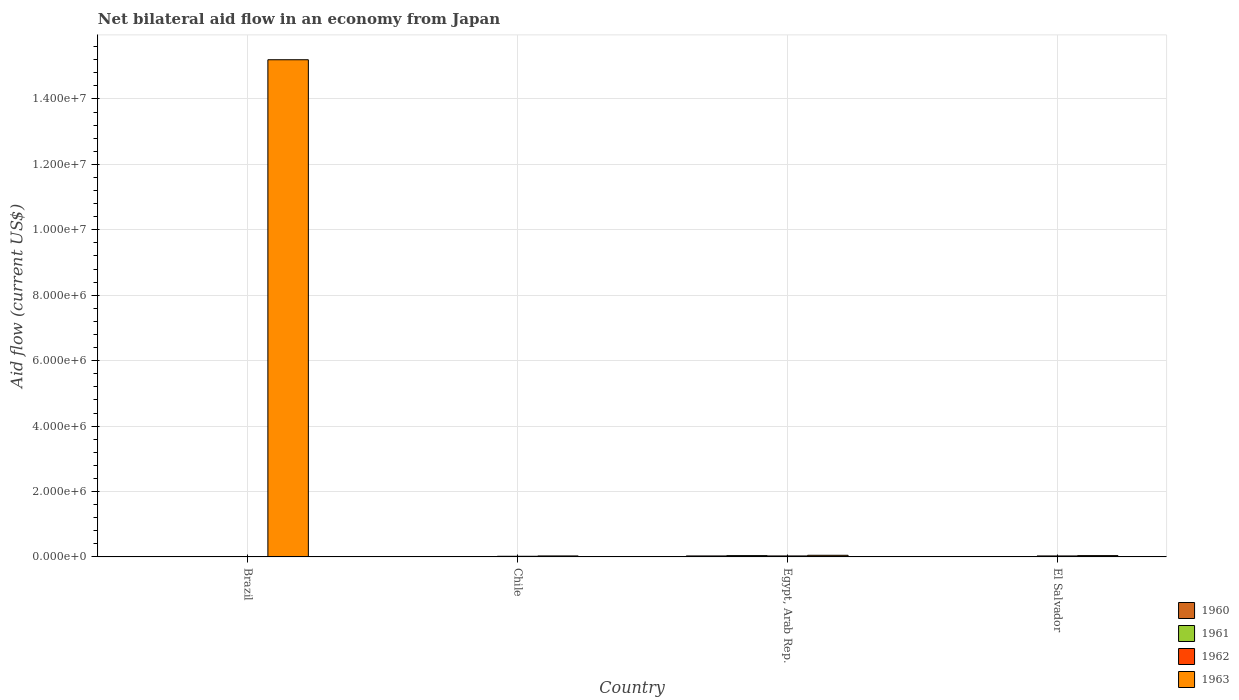Are the number of bars per tick equal to the number of legend labels?
Your answer should be compact. No. Are the number of bars on each tick of the X-axis equal?
Make the answer very short. No. How many bars are there on the 2nd tick from the left?
Provide a succinct answer. 4. What is the label of the 2nd group of bars from the left?
Your answer should be compact. Chile. What is the net bilateral aid flow in 1960 in Brazil?
Provide a succinct answer. 0. Across all countries, what is the maximum net bilateral aid flow in 1963?
Provide a succinct answer. 1.52e+07. In which country was the net bilateral aid flow in 1960 maximum?
Your answer should be very brief. Egypt, Arab Rep. What is the total net bilateral aid flow in 1963 in the graph?
Keep it short and to the point. 1.53e+07. What is the difference between the net bilateral aid flow in 1960 in Egypt, Arab Rep. and that in El Salvador?
Offer a very short reply. 2.00e+04. What is the difference between the net bilateral aid flow in 1962 in Egypt, Arab Rep. and the net bilateral aid flow in 1960 in El Salvador?
Provide a succinct answer. 2.00e+04. What is the average net bilateral aid flow in 1961 per country?
Keep it short and to the point. 1.50e+04. What is the difference between the net bilateral aid flow of/in 1963 and net bilateral aid flow of/in 1962 in El Salvador?
Keep it short and to the point. 10000. Is the difference between the net bilateral aid flow in 1963 in Chile and Egypt, Arab Rep. greater than the difference between the net bilateral aid flow in 1962 in Chile and Egypt, Arab Rep.?
Offer a terse response. No. What is the difference between the highest and the second highest net bilateral aid flow in 1962?
Offer a very short reply. 10000. In how many countries, is the net bilateral aid flow in 1960 greater than the average net bilateral aid flow in 1960 taken over all countries?
Give a very brief answer. 1. Is the sum of the net bilateral aid flow in 1963 in Brazil and Chile greater than the maximum net bilateral aid flow in 1961 across all countries?
Provide a short and direct response. Yes. Is it the case that in every country, the sum of the net bilateral aid flow in 1961 and net bilateral aid flow in 1963 is greater than the sum of net bilateral aid flow in 1962 and net bilateral aid flow in 1960?
Offer a terse response. No. Is it the case that in every country, the sum of the net bilateral aid flow in 1963 and net bilateral aid flow in 1961 is greater than the net bilateral aid flow in 1962?
Offer a very short reply. Yes. Are all the bars in the graph horizontal?
Offer a terse response. No. Are the values on the major ticks of Y-axis written in scientific E-notation?
Give a very brief answer. Yes. How are the legend labels stacked?
Your answer should be very brief. Vertical. What is the title of the graph?
Your answer should be compact. Net bilateral aid flow in an economy from Japan. Does "1976" appear as one of the legend labels in the graph?
Make the answer very short. No. What is the Aid flow (current US$) of 1960 in Brazil?
Your response must be concise. 0. What is the Aid flow (current US$) in 1963 in Brazil?
Provide a succinct answer. 1.52e+07. What is the Aid flow (current US$) of 1961 in Chile?
Provide a succinct answer. 10000. What is the Aid flow (current US$) of 1962 in Chile?
Ensure brevity in your answer.  2.00e+04. What is the Aid flow (current US$) of 1961 in Egypt, Arab Rep.?
Your answer should be compact. 4.00e+04. What is the Aid flow (current US$) of 1961 in El Salvador?
Give a very brief answer. 10000. Across all countries, what is the maximum Aid flow (current US$) of 1961?
Offer a very short reply. 4.00e+04. Across all countries, what is the maximum Aid flow (current US$) in 1962?
Provide a short and direct response. 3.00e+04. Across all countries, what is the maximum Aid flow (current US$) of 1963?
Provide a succinct answer. 1.52e+07. Across all countries, what is the minimum Aid flow (current US$) in 1960?
Your answer should be very brief. 0. What is the total Aid flow (current US$) of 1962 in the graph?
Provide a succinct answer. 8.00e+04. What is the total Aid flow (current US$) in 1963 in the graph?
Keep it short and to the point. 1.53e+07. What is the difference between the Aid flow (current US$) of 1963 in Brazil and that in Chile?
Offer a terse response. 1.52e+07. What is the difference between the Aid flow (current US$) in 1963 in Brazil and that in Egypt, Arab Rep.?
Ensure brevity in your answer.  1.52e+07. What is the difference between the Aid flow (current US$) of 1963 in Brazil and that in El Salvador?
Offer a very short reply. 1.52e+07. What is the difference between the Aid flow (current US$) of 1960 in Chile and that in Egypt, Arab Rep.?
Your answer should be compact. -2.00e+04. What is the difference between the Aid flow (current US$) of 1963 in Chile and that in Egypt, Arab Rep.?
Offer a terse response. -2.00e+04. What is the difference between the Aid flow (current US$) of 1960 in Chile and that in El Salvador?
Offer a very short reply. 0. What is the difference between the Aid flow (current US$) in 1962 in Chile and that in El Salvador?
Keep it short and to the point. -10000. What is the difference between the Aid flow (current US$) of 1963 in Chile and that in El Salvador?
Keep it short and to the point. -10000. What is the difference between the Aid flow (current US$) of 1961 in Egypt, Arab Rep. and that in El Salvador?
Keep it short and to the point. 3.00e+04. What is the difference between the Aid flow (current US$) in 1962 in Egypt, Arab Rep. and that in El Salvador?
Offer a terse response. 0. What is the difference between the Aid flow (current US$) of 1960 in Chile and the Aid flow (current US$) of 1961 in Egypt, Arab Rep.?
Make the answer very short. -3.00e+04. What is the difference between the Aid flow (current US$) of 1961 in Chile and the Aid flow (current US$) of 1962 in Egypt, Arab Rep.?
Provide a succinct answer. -2.00e+04. What is the difference between the Aid flow (current US$) in 1962 in Chile and the Aid flow (current US$) in 1963 in Egypt, Arab Rep.?
Offer a very short reply. -3.00e+04. What is the difference between the Aid flow (current US$) in 1960 in Chile and the Aid flow (current US$) in 1962 in El Salvador?
Your answer should be very brief. -2.00e+04. What is the difference between the Aid flow (current US$) of 1960 in Chile and the Aid flow (current US$) of 1963 in El Salvador?
Provide a short and direct response. -3.00e+04. What is the difference between the Aid flow (current US$) in 1961 in Chile and the Aid flow (current US$) in 1962 in El Salvador?
Give a very brief answer. -2.00e+04. What is the difference between the Aid flow (current US$) of 1962 in Chile and the Aid flow (current US$) of 1963 in El Salvador?
Your answer should be compact. -2.00e+04. What is the difference between the Aid flow (current US$) of 1960 in Egypt, Arab Rep. and the Aid flow (current US$) of 1961 in El Salvador?
Your answer should be compact. 2.00e+04. What is the difference between the Aid flow (current US$) in 1960 in Egypt, Arab Rep. and the Aid flow (current US$) in 1963 in El Salvador?
Provide a short and direct response. -10000. What is the average Aid flow (current US$) of 1960 per country?
Offer a very short reply. 1.25e+04. What is the average Aid flow (current US$) of 1961 per country?
Provide a short and direct response. 1.50e+04. What is the average Aid flow (current US$) of 1963 per country?
Make the answer very short. 3.83e+06. What is the difference between the Aid flow (current US$) in 1960 and Aid flow (current US$) in 1961 in Chile?
Your response must be concise. 0. What is the difference between the Aid flow (current US$) of 1961 and Aid flow (current US$) of 1962 in Chile?
Your answer should be compact. -10000. What is the difference between the Aid flow (current US$) in 1960 and Aid flow (current US$) in 1961 in Egypt, Arab Rep.?
Your answer should be compact. -10000. What is the difference between the Aid flow (current US$) in 1961 and Aid flow (current US$) in 1963 in Egypt, Arab Rep.?
Provide a succinct answer. -10000. What is the difference between the Aid flow (current US$) in 1960 and Aid flow (current US$) in 1963 in El Salvador?
Ensure brevity in your answer.  -3.00e+04. What is the difference between the Aid flow (current US$) of 1962 and Aid flow (current US$) of 1963 in El Salvador?
Offer a terse response. -10000. What is the ratio of the Aid flow (current US$) in 1963 in Brazil to that in Chile?
Keep it short and to the point. 506.67. What is the ratio of the Aid flow (current US$) in 1963 in Brazil to that in Egypt, Arab Rep.?
Your answer should be compact. 304. What is the ratio of the Aid flow (current US$) in 1963 in Brazil to that in El Salvador?
Make the answer very short. 380. What is the ratio of the Aid flow (current US$) of 1960 in Chile to that in Egypt, Arab Rep.?
Offer a very short reply. 0.33. What is the ratio of the Aid flow (current US$) in 1961 in Chile to that in El Salvador?
Offer a terse response. 1. What is the ratio of the Aid flow (current US$) in 1962 in Chile to that in El Salvador?
Your response must be concise. 0.67. What is the ratio of the Aid flow (current US$) in 1963 in Chile to that in El Salvador?
Provide a short and direct response. 0.75. What is the ratio of the Aid flow (current US$) of 1963 in Egypt, Arab Rep. to that in El Salvador?
Offer a very short reply. 1.25. What is the difference between the highest and the second highest Aid flow (current US$) of 1960?
Offer a very short reply. 2.00e+04. What is the difference between the highest and the second highest Aid flow (current US$) of 1962?
Provide a succinct answer. 0. What is the difference between the highest and the second highest Aid flow (current US$) of 1963?
Make the answer very short. 1.52e+07. What is the difference between the highest and the lowest Aid flow (current US$) in 1963?
Ensure brevity in your answer.  1.52e+07. 